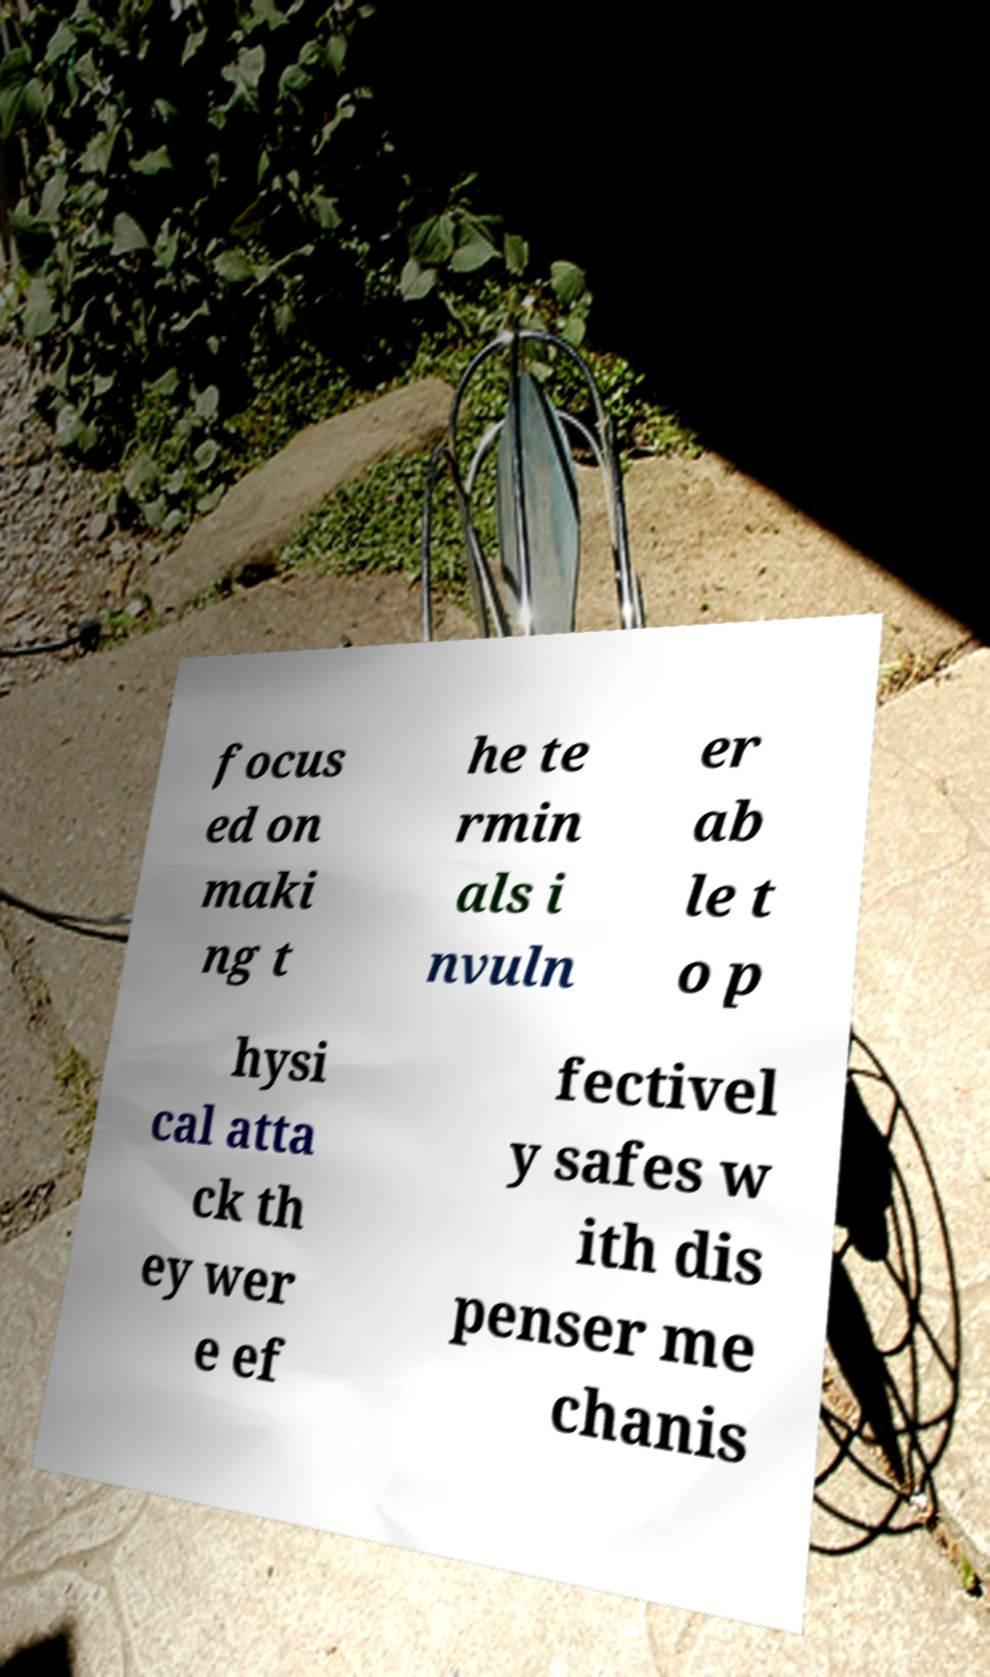Please identify and transcribe the text found in this image. focus ed on maki ng t he te rmin als i nvuln er ab le t o p hysi cal atta ck th ey wer e ef fectivel y safes w ith dis penser me chanis 